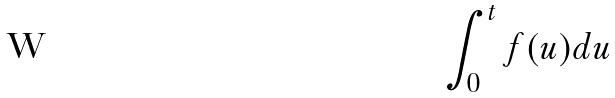<formula> <loc_0><loc_0><loc_500><loc_500>\int _ { 0 } ^ { t } f ( u ) d u</formula> 